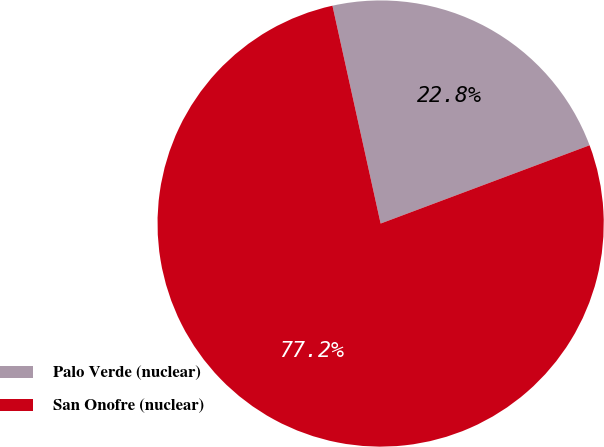Convert chart. <chart><loc_0><loc_0><loc_500><loc_500><pie_chart><fcel>Palo Verde (nuclear)<fcel>San Onofre (nuclear)<nl><fcel>22.76%<fcel>77.24%<nl></chart> 